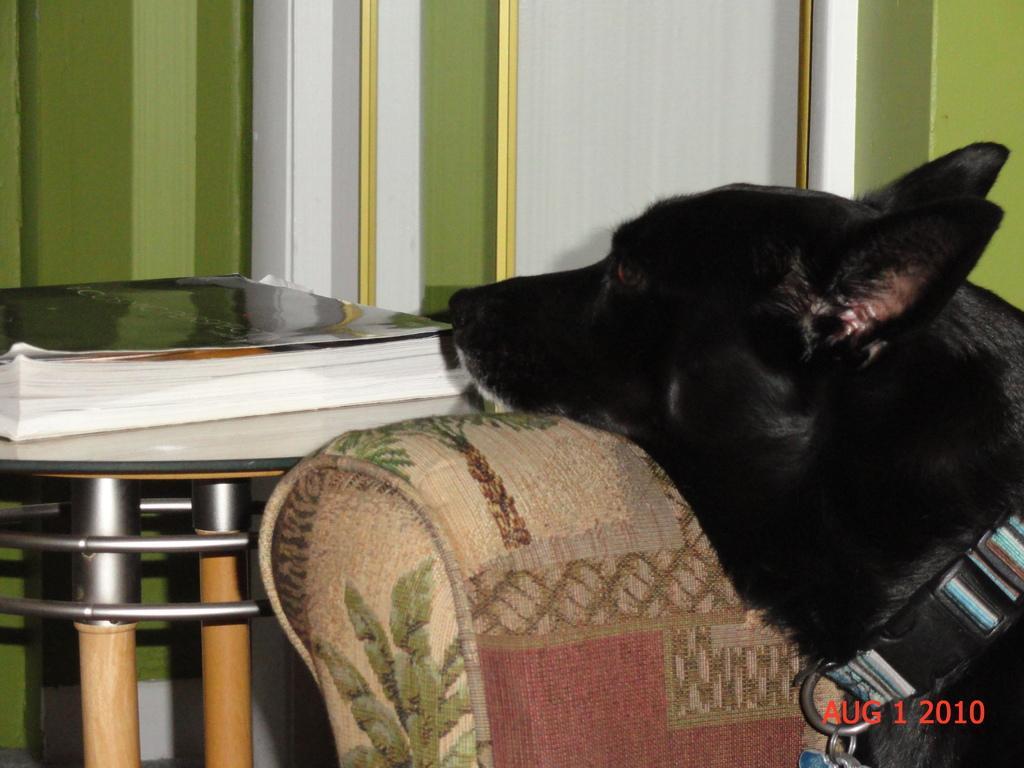Describe this image in one or two sentences. In this image, on the right side there is a dog sitting on a sofa, on the left side there is table, on that table there are books, in the background there a wall, in the bottom right there is date. 